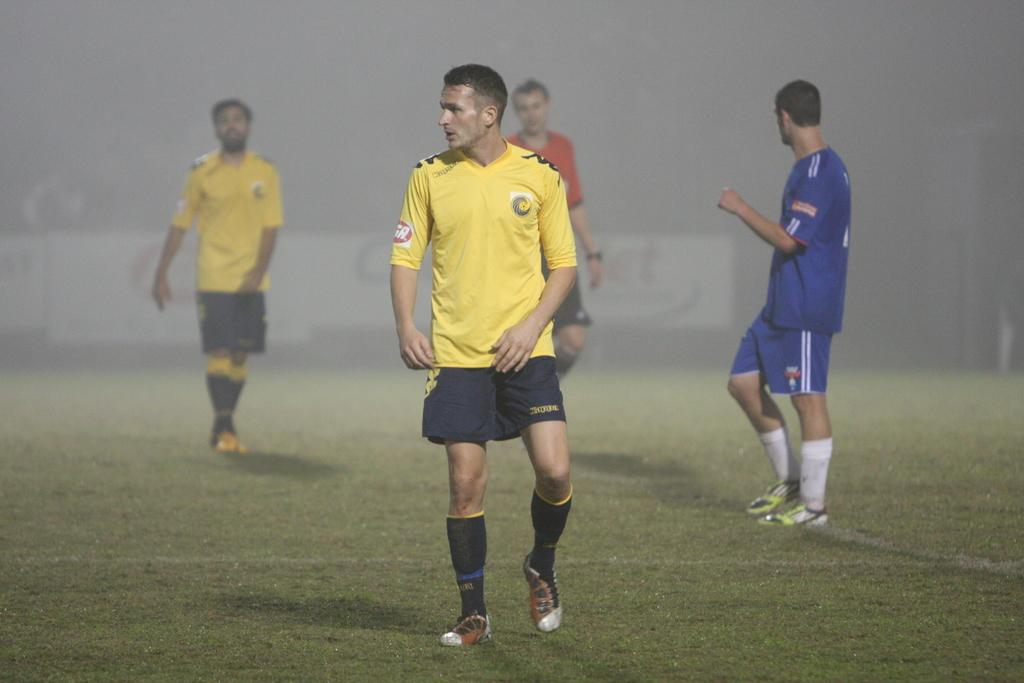What are the people in the image doing? The people in the image are walking on the ground. Can you describe the background in the image? The background in the image is not clear. What type of canvas is visible in the image? There is no canvas present in the image. What flavor of road can be seen in the image? There is no road present in the image, and therefore no flavor can be determined. 